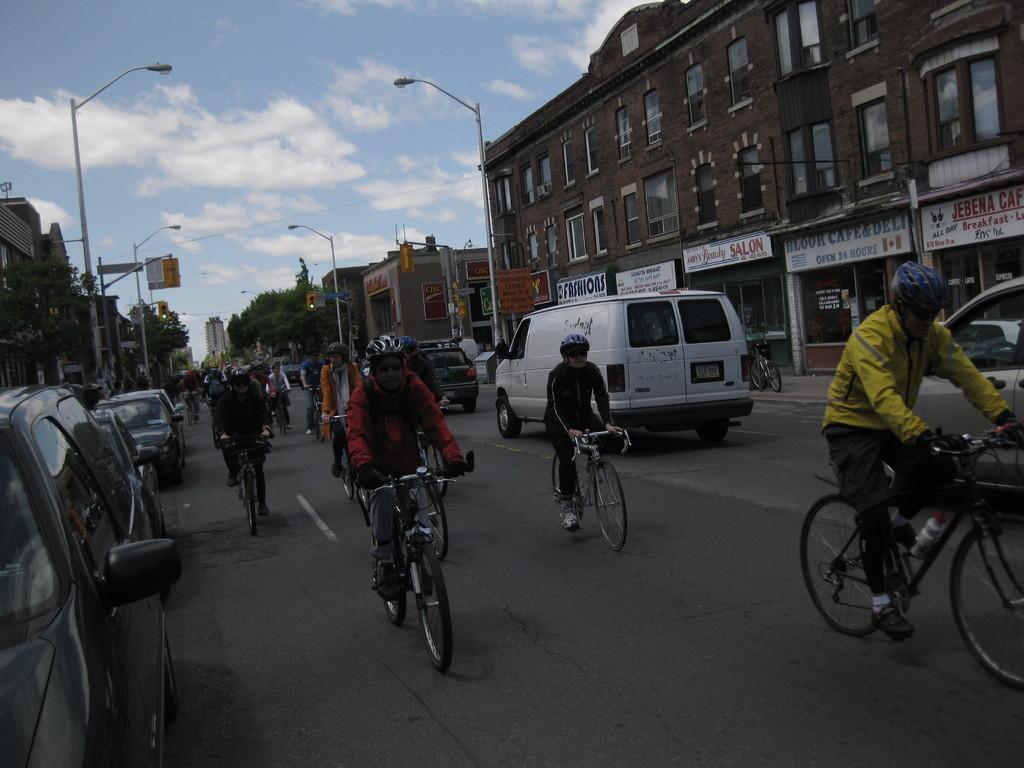In one or two sentences, can you explain what this image depicts? In this picture we can see many peoples were riding the bicycle. Besides the road we can see many cars. On the right and left side we can see the buildings, street lights, trees, sign boards and traffic signal. At the building we can see doors, windows and boards. At the top we can see sky and clouds. 